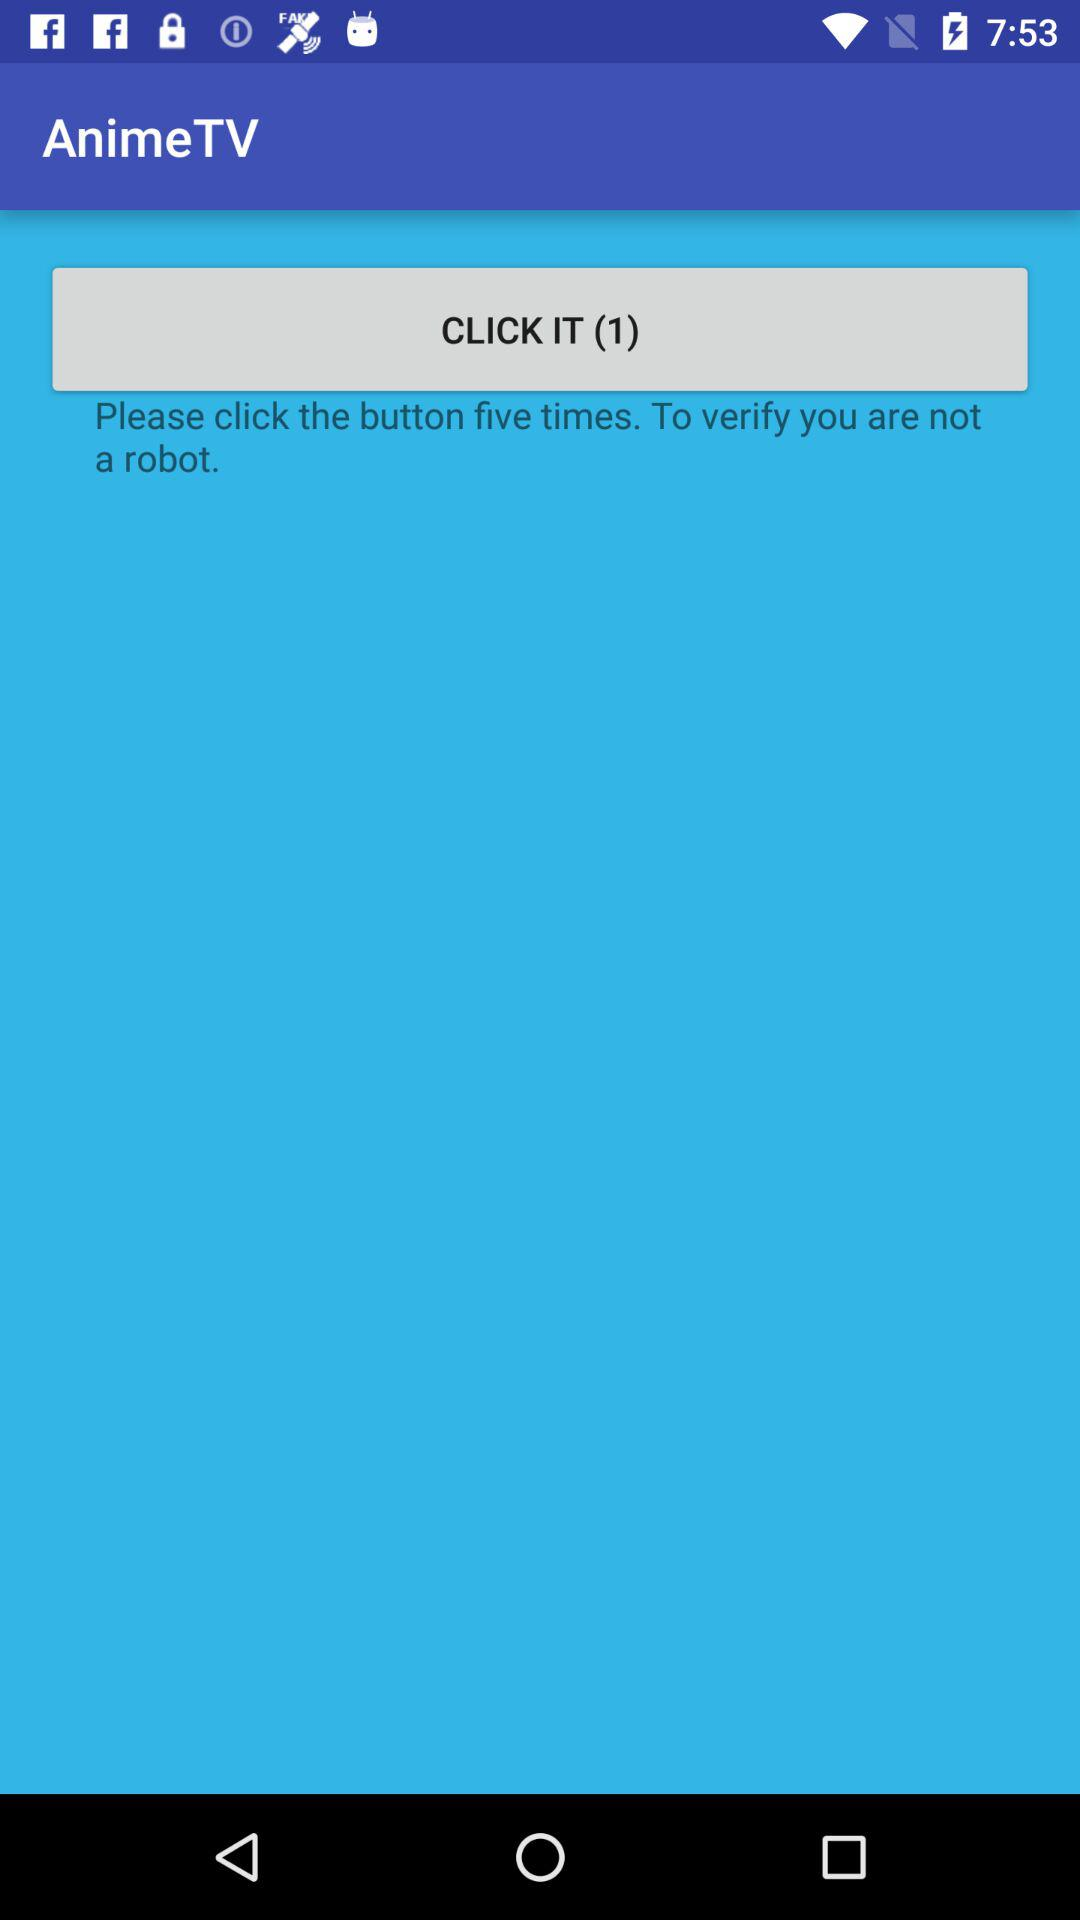How many times do we have to click the button to verify that we are not robots? You have to click the button five times. 